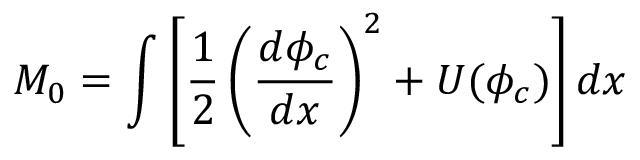Convert formula to latex. <formula><loc_0><loc_0><loc_500><loc_500>M _ { 0 } = \int \left [ \frac { 1 } { 2 } \left ( \frac { d \phi _ { c } } { d x } \right ) ^ { 2 } + U ( \phi _ { c } ) \right ] d x</formula> 